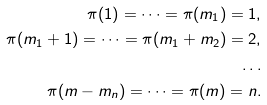Convert formula to latex. <formula><loc_0><loc_0><loc_500><loc_500>\pi ( 1 ) = \dots = \pi ( m _ { 1 } ) = 1 , \\ \pi ( m _ { 1 } + 1 ) = \dots = \pi ( m _ { 1 } + m _ { 2 } ) = 2 , \\ \hdots \\ \pi ( m - m _ { n } ) = \dots = \pi ( m ) = n .</formula> 